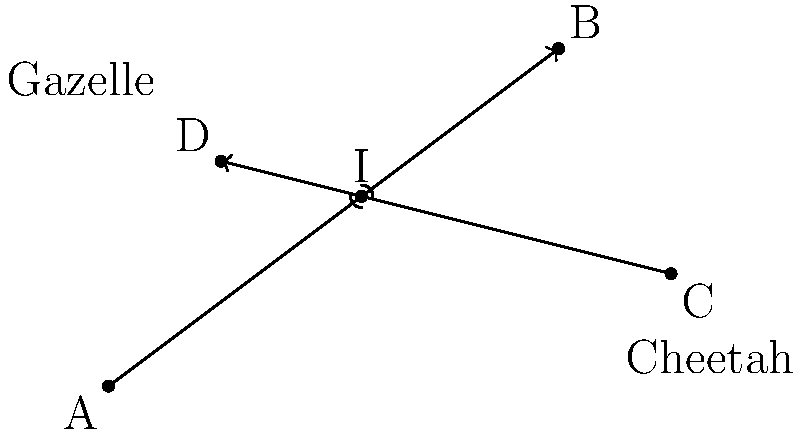As a wildlife photographer, you're tracking a cheetah chasing a gazelle. The cheetah's path can be represented by the line passing through points A(0,0) and B(8,6), while the gazelle's path is represented by the line passing through points C(10,2) and D(2,4). Determine the coordinates of the intersection point I, where the paths of the two animals cross, to anticipate the best position for capturing the chase. To find the intersection point of the two paths, we need to follow these steps:

1) First, let's find the equations of both lines:

   For line AB (cheetah's path):
   Slope $m_{AB} = \frac{6-0}{8-0} = \frac{3}{4}$
   Equation: $y = \frac{3}{4}x$

   For line CD (gazelle's path):
   Slope $m_{CD} = \frac{2-4}{10-2} = -\frac{1}{4}$
   Equation: $y = -\frac{1}{4}x + 4.5$ (using point-slope form and point C)

2) To find the intersection point, we set these equations equal to each other:

   $\frac{3}{4}x = -\frac{1}{4}x + 4.5$

3) Solve for x:
   $\frac{3}{4}x + \frac{1}{4}x = 4.5$
   $x = 4.5$

4) Substitute this x-value back into either equation to find y:
   $y = \frac{3}{4}(4.5) = \frac{27}{8} = 3.375$

5) Therefore, the intersection point I has coordinates (4.5, 3.375).
Answer: (4.5, 3.375) 